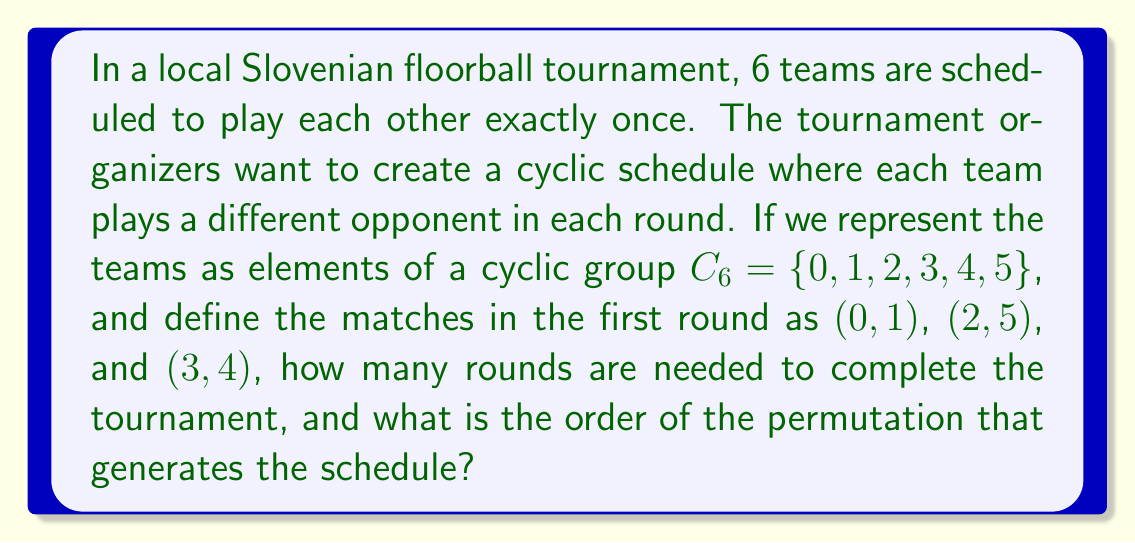Can you solve this math problem? Let's approach this step-by-step:

1) In a cyclic group $C_6$, we can represent the teams as elements $\{0, 1, 2, 3, 4, 5\}$.

2) The first round matches are given as $(0,1)$, $(2,5)$, and $(3,4)$.

3) To generate the next round, we need to apply a permutation that rotates all elements. The permutation that works here is:

   $\sigma = (0 \, 1 \, 2 \, 3 \, 4 \, 5)$

4) Applying $\sigma$ to the first round matches:
   Round 1: $(0,1)$, $(2,5)$, $(3,4)$
   Round 2: $(1,2)$, $(3,0)$, $(4,5)$
   Round 3: $(2,3)$, $(4,1)$, $(5,0)$
   Round 4: $(3,4)$, $(5,2)$, $(0,1)$
   Round 5: $(4,5)$, $(0,3)$, $(1,2)$

5) We see that after 5 rounds, each team has played every other team exactly once.

6) The order of the permutation $\sigma$ is 6, as it takes 6 applications to return to the identity permutation. However, we only need 5 rounds to complete the tournament.

7) This is because in a tournament with $n$ teams, where $n$ is even, we need $n-1$ rounds to ensure each team plays every other team once.
Answer: The tournament requires 5 rounds to complete, and the order of the generating permutation $\sigma = (0 \, 1 \, 2 \, 3 \, 4 \, 5)$ is 6. 